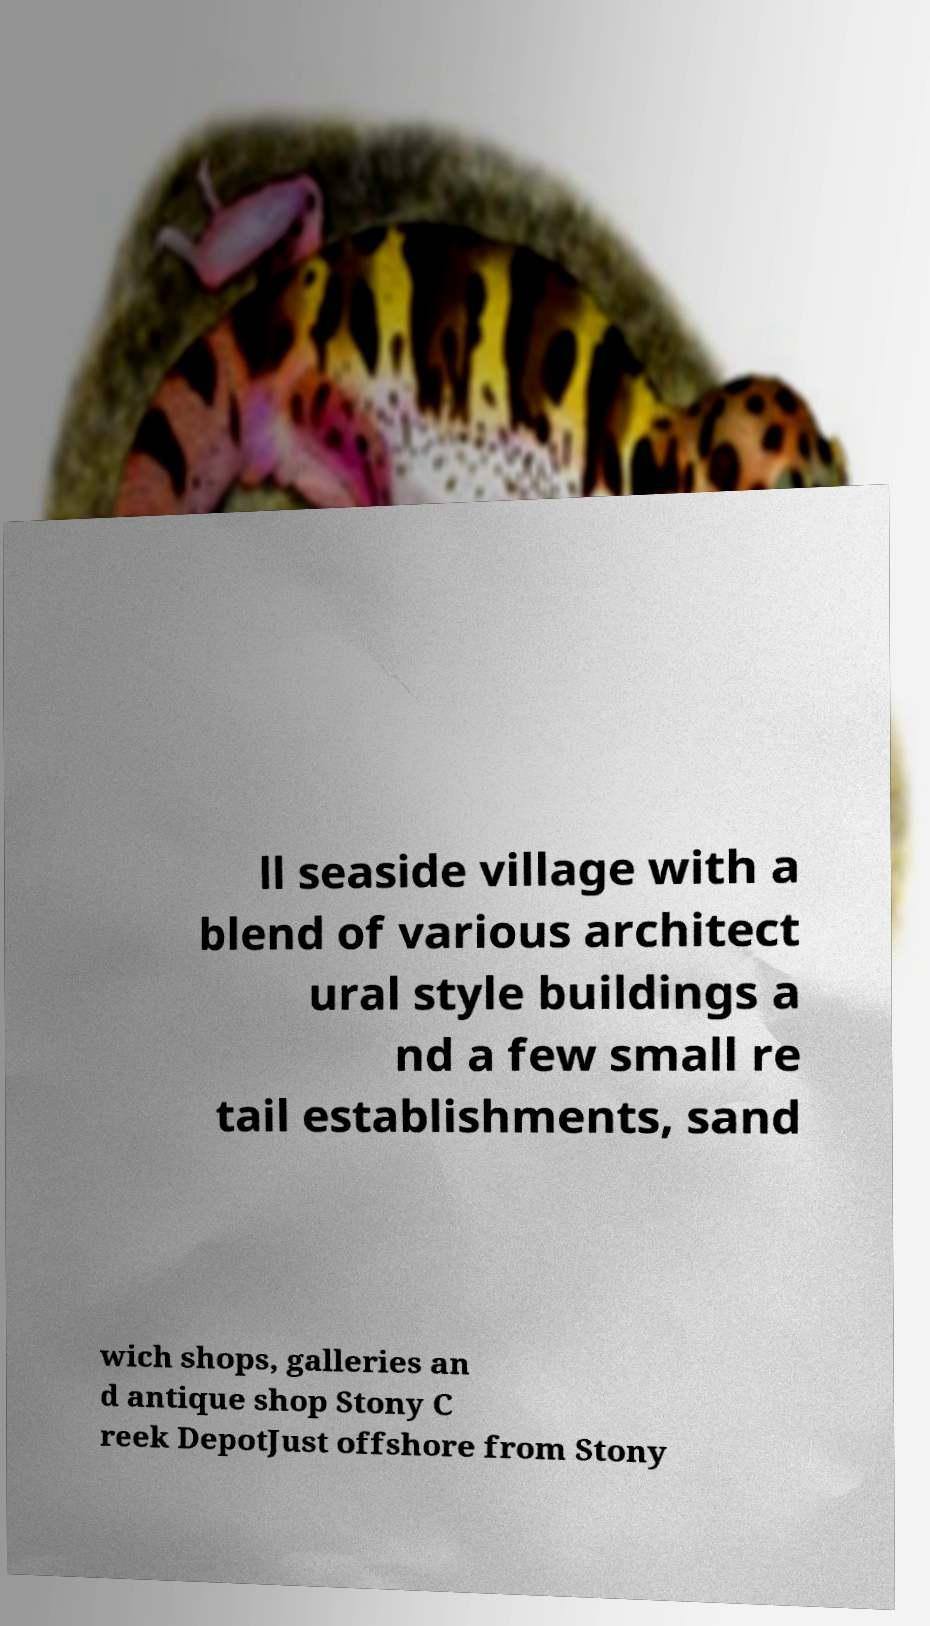Please read and relay the text visible in this image. What does it say? ll seaside village with a blend of various architect ural style buildings a nd a few small re tail establishments, sand wich shops, galleries an d antique shop Stony C reek DepotJust offshore from Stony 